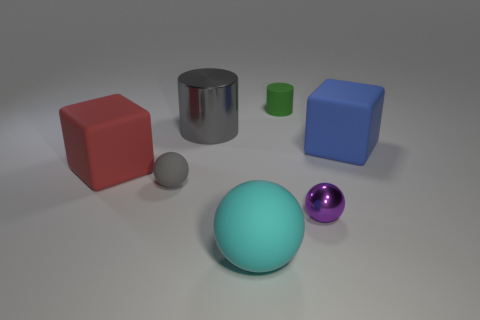What is the material of the gray ball?
Provide a short and direct response. Rubber. What is the material of the large object that is both in front of the large blue matte cube and behind the metal sphere?
Provide a short and direct response. Rubber. Is the color of the metallic sphere the same as the large block that is on the left side of the green rubber object?
Give a very brief answer. No. What is the material of the ball that is the same size as the metallic cylinder?
Offer a very short reply. Rubber. Is there a large yellow block made of the same material as the small green cylinder?
Make the answer very short. No. How many tiny blue balls are there?
Offer a very short reply. 0. Is the material of the large red object the same as the purple ball that is behind the large cyan matte object?
Provide a short and direct response. No. There is a sphere that is the same color as the metal cylinder; what material is it?
Offer a very short reply. Rubber. What number of shiny objects have the same color as the matte cylinder?
Your answer should be very brief. 0. What is the size of the green matte cylinder?
Provide a succinct answer. Small. 